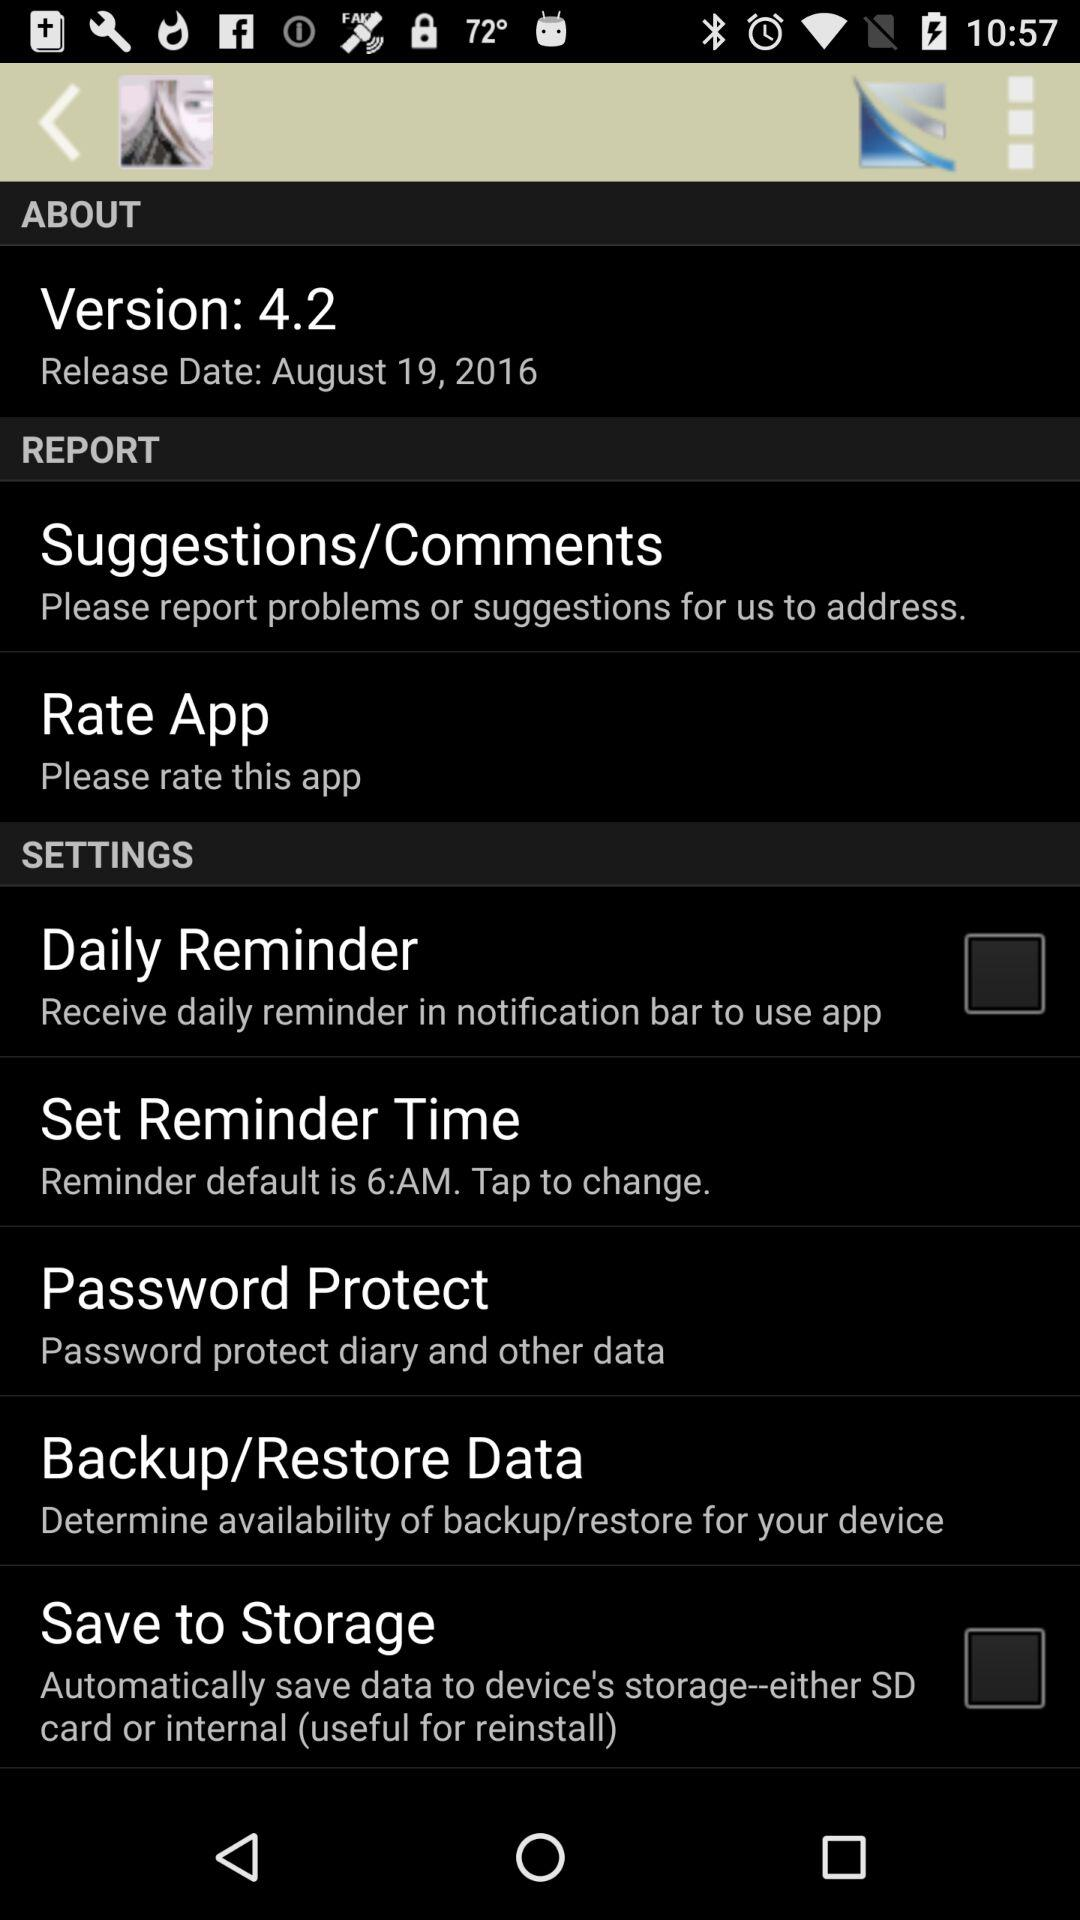What is the version of the app? The version of the app is 4.2. 